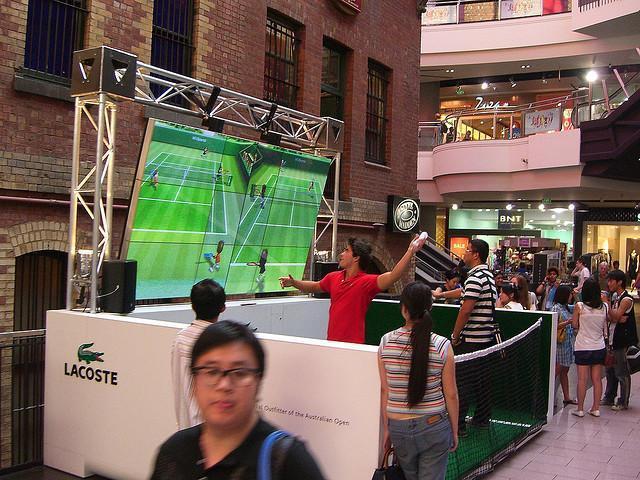How many people are visible?
Give a very brief answer. 8. 